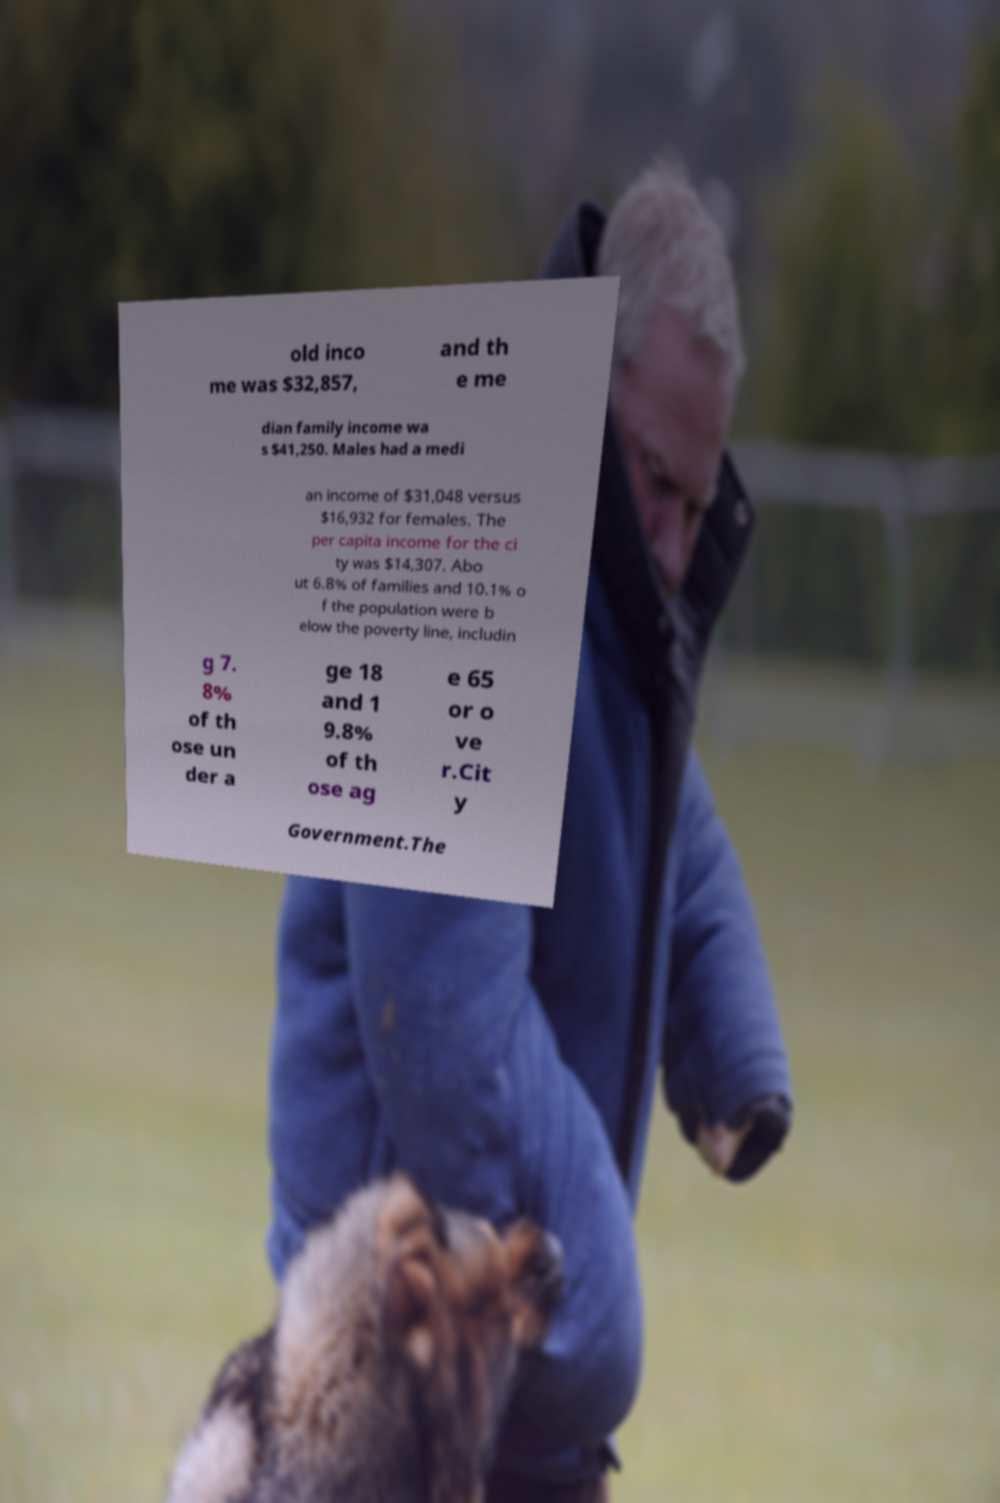Could you extract and type out the text from this image? old inco me was $32,857, and th e me dian family income wa s $41,250. Males had a medi an income of $31,048 versus $16,932 for females. The per capita income for the ci ty was $14,307. Abo ut 6.8% of families and 10.1% o f the population were b elow the poverty line, includin g 7. 8% of th ose un der a ge 18 and 1 9.8% of th ose ag e 65 or o ve r.Cit y Government.The 